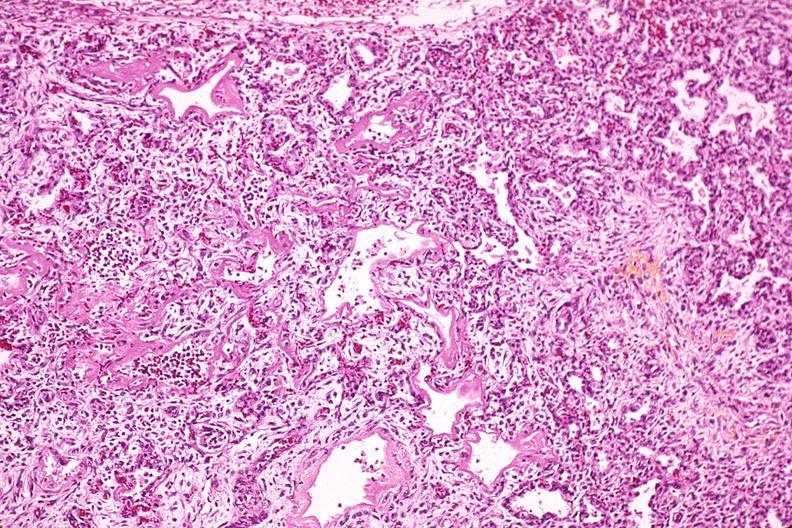s periprostatic vein thrombi present?
Answer the question using a single word or phrase. No 